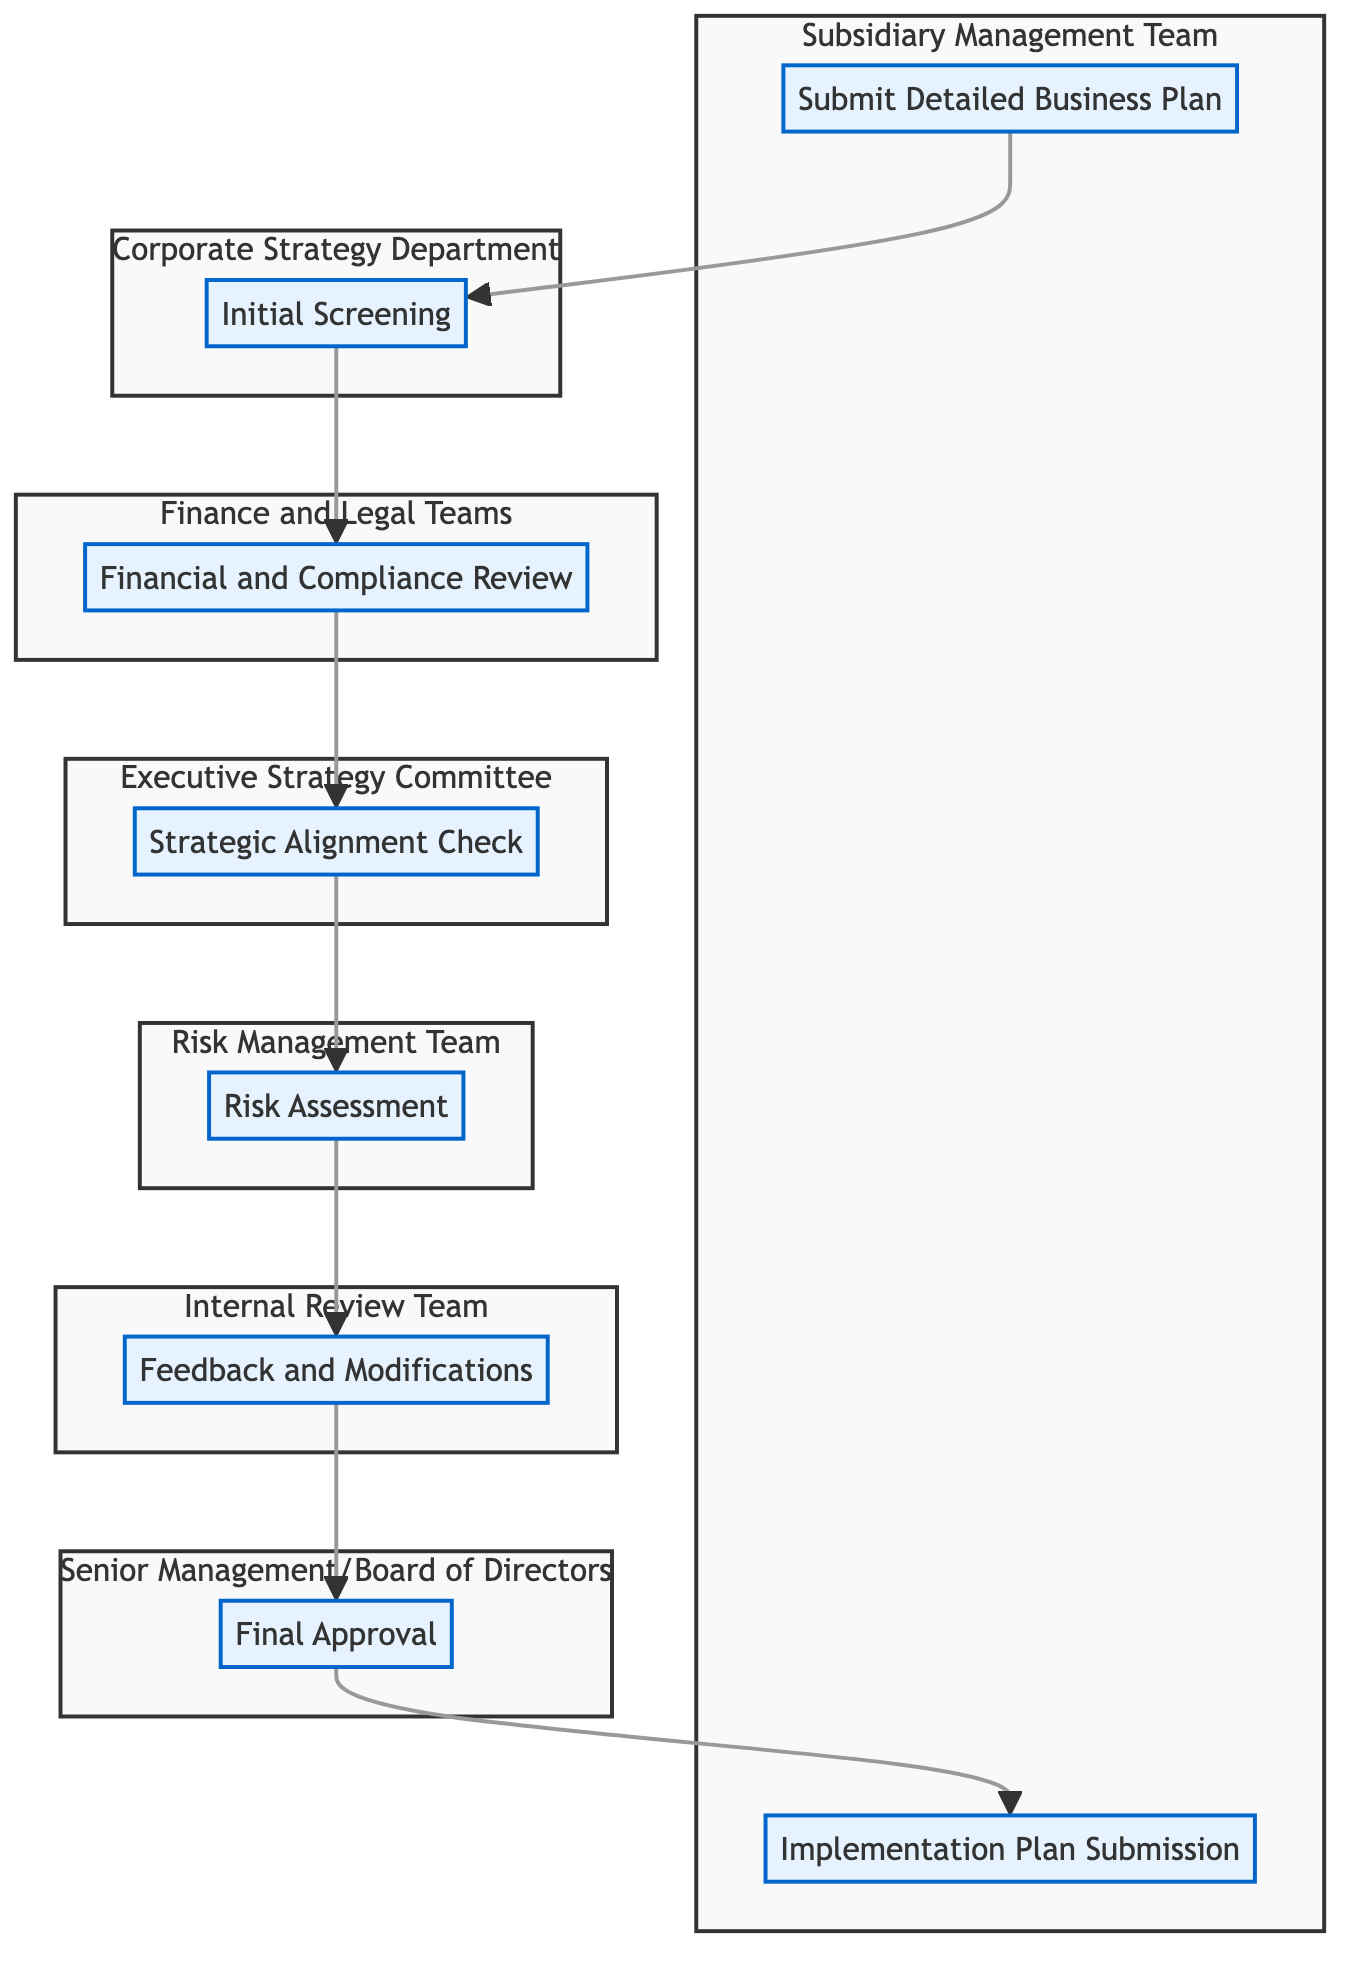What is the last step in the workflow? The workflow ends with the node labeled "Implementation Plan Submission." This is where the subsidiary submits a detailed plan for implementing the approved strategies after the final approval.
Answer: Implementation Plan Submission How many distinct teams are involved in the approval process? There are six distinct teams listed in the diagram: Subsidiary Management Team, Corporate Strategy Department, Finance and Legal Teams, Executive Strategy Committee, Risk Management Team, and Senior Management/Board of Directors. By counting each of these teams, we find that there are six.
Answer: 6 What is the primary task of the Financial and Compliance Review step? The "Financial and Compliance Review" step involves a detailed analysis of financial projections and compliance with regulatory requirements. This indicates the importance of financial oversight in the process.
Answer: Detailed analysis of financial projections and compliance Which entity conducts the Initial Screening? The "Initial Screening" step is performed by the "Corporate Strategy Department." This shows that they are responsible for evaluating the business plan's alignment with corporate goals.
Answer: Corporate Strategy Department What comes directly after the Risk Assessment step? Directly following the "Risk Assessment" step is the "Feedback and Modifications" step. This indicates that after assessing risks, feedback is provided to the subsidiary for improvements.
Answer: Feedback and Modifications What is the relationship between Final Approval and Implementation Plan Submission? The relationship is sequential; "Final Approval" must occur before the "Implementation Plan Submission" step. This indicates that only after receiving final approval can the subsidiary submit implementation details.
Answer: Sequential relationship Which step is most likely to involve modifications? The step labeled "Feedback and Modifications" is specifically designed for this purpose, where the internal review team provides feedback for necessary changes.
Answer: Feedback and Modifications What does the Initial Screening evaluate? The "Initial Screening" evaluates the submitted business plan for alignment with corporate goals and preliminary feasibility, ensuring that proposals fit within the corporate framework.
Answer: Alignment with corporate goals and preliminary feasibility 